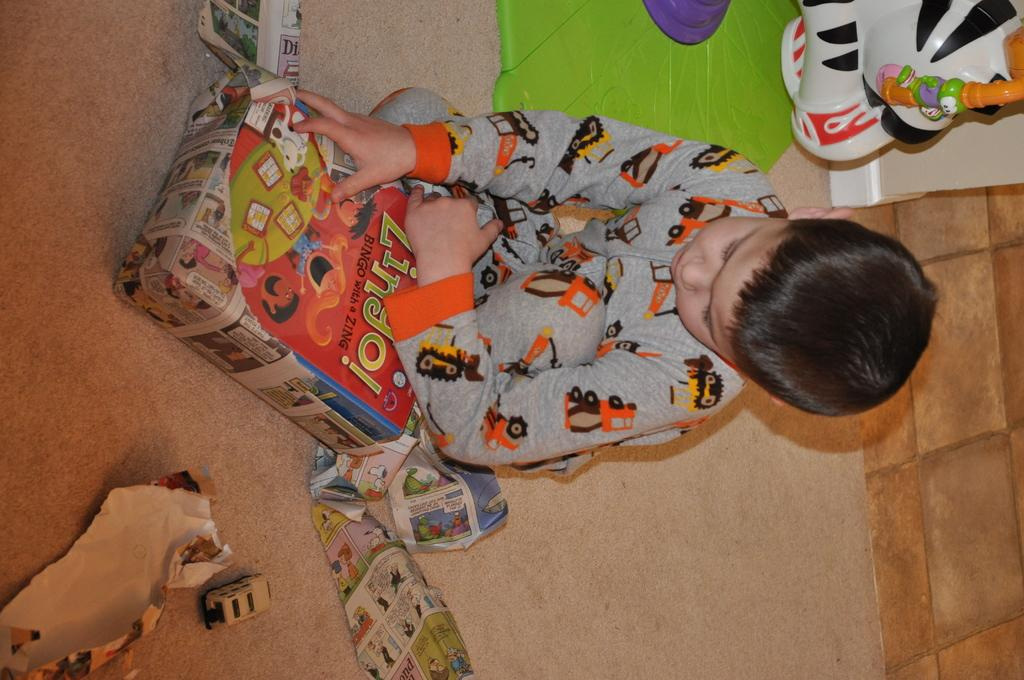What is the boy in the image doing? The boy is sitting in the image. What can be seen on the floor in the image? There are objects on the floor in the image. Where is the toy located in the image? The toy is in the top right corner of the image. What type of wall is visible on the right side of the image? There is a wall with brown bricks on the right side of the image. How does the dirt on the floor contribute to the boy's approval in the image? There is no dirt visible on the floor in the image, and therefore it cannot contribute to the boy's approval. 